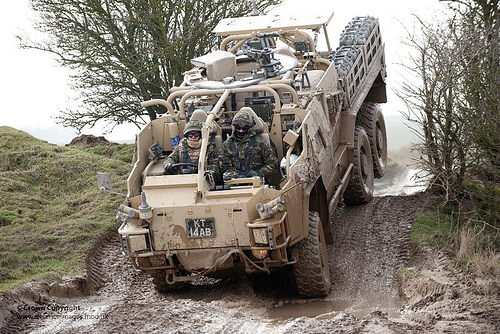<image>
Is the wheel on the ground? No. The wheel is not positioned on the ground. They may be near each other, but the wheel is not supported by or resting on top of the ground. 